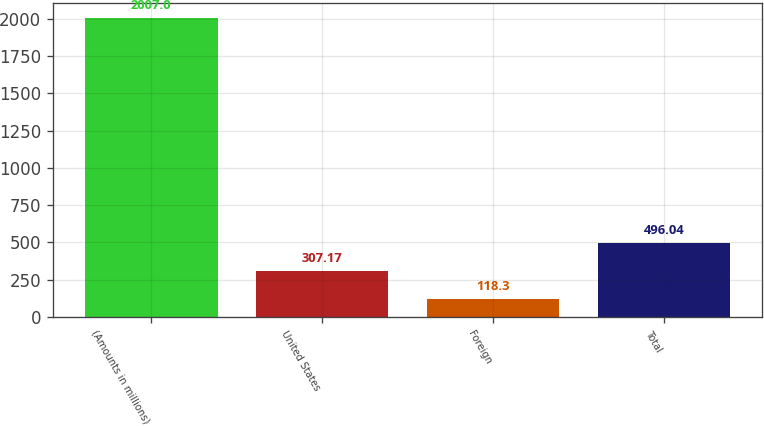Convert chart. <chart><loc_0><loc_0><loc_500><loc_500><bar_chart><fcel>(Amounts in millions)<fcel>United States<fcel>Foreign<fcel>Total<nl><fcel>2007<fcel>307.17<fcel>118.3<fcel>496.04<nl></chart> 